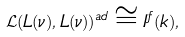<formula> <loc_0><loc_0><loc_500><loc_500>\mathcal { L } ( L ( \nu ) , L ( \nu ) ) ^ { a d } \cong I ^ { f } ( k ) ,</formula> 